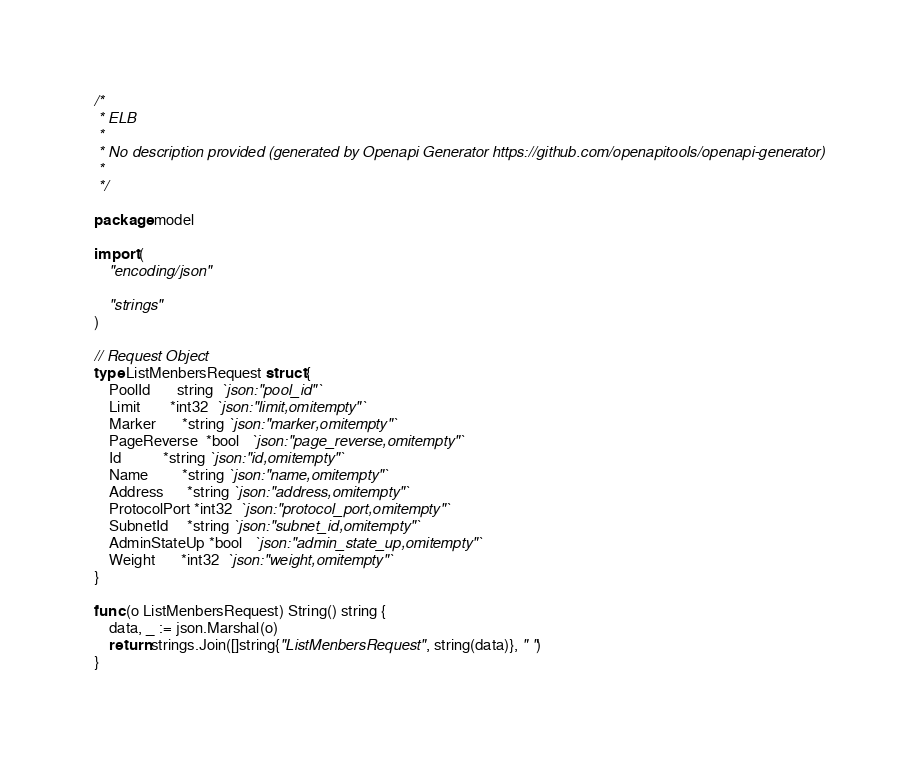<code> <loc_0><loc_0><loc_500><loc_500><_Go_>/*
 * ELB
 *
 * No description provided (generated by Openapi Generator https://github.com/openapitools/openapi-generator)
 *
 */

package model

import (
	"encoding/json"

	"strings"
)

// Request Object
type ListMenbersRequest struct {
	PoolId       string  `json:"pool_id"`
	Limit        *int32  `json:"limit,omitempty"`
	Marker       *string `json:"marker,omitempty"`
	PageReverse  *bool   `json:"page_reverse,omitempty"`
	Id           *string `json:"id,omitempty"`
	Name         *string `json:"name,omitempty"`
	Address      *string `json:"address,omitempty"`
	ProtocolPort *int32  `json:"protocol_port,omitempty"`
	SubnetId     *string `json:"subnet_id,omitempty"`
	AdminStateUp *bool   `json:"admin_state_up,omitempty"`
	Weight       *int32  `json:"weight,omitempty"`
}

func (o ListMenbersRequest) String() string {
	data, _ := json.Marshal(o)
	return strings.Join([]string{"ListMenbersRequest", string(data)}, " ")
}
</code> 